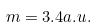<formula> <loc_0><loc_0><loc_500><loc_500>m = 3 . 4 a . u .</formula> 